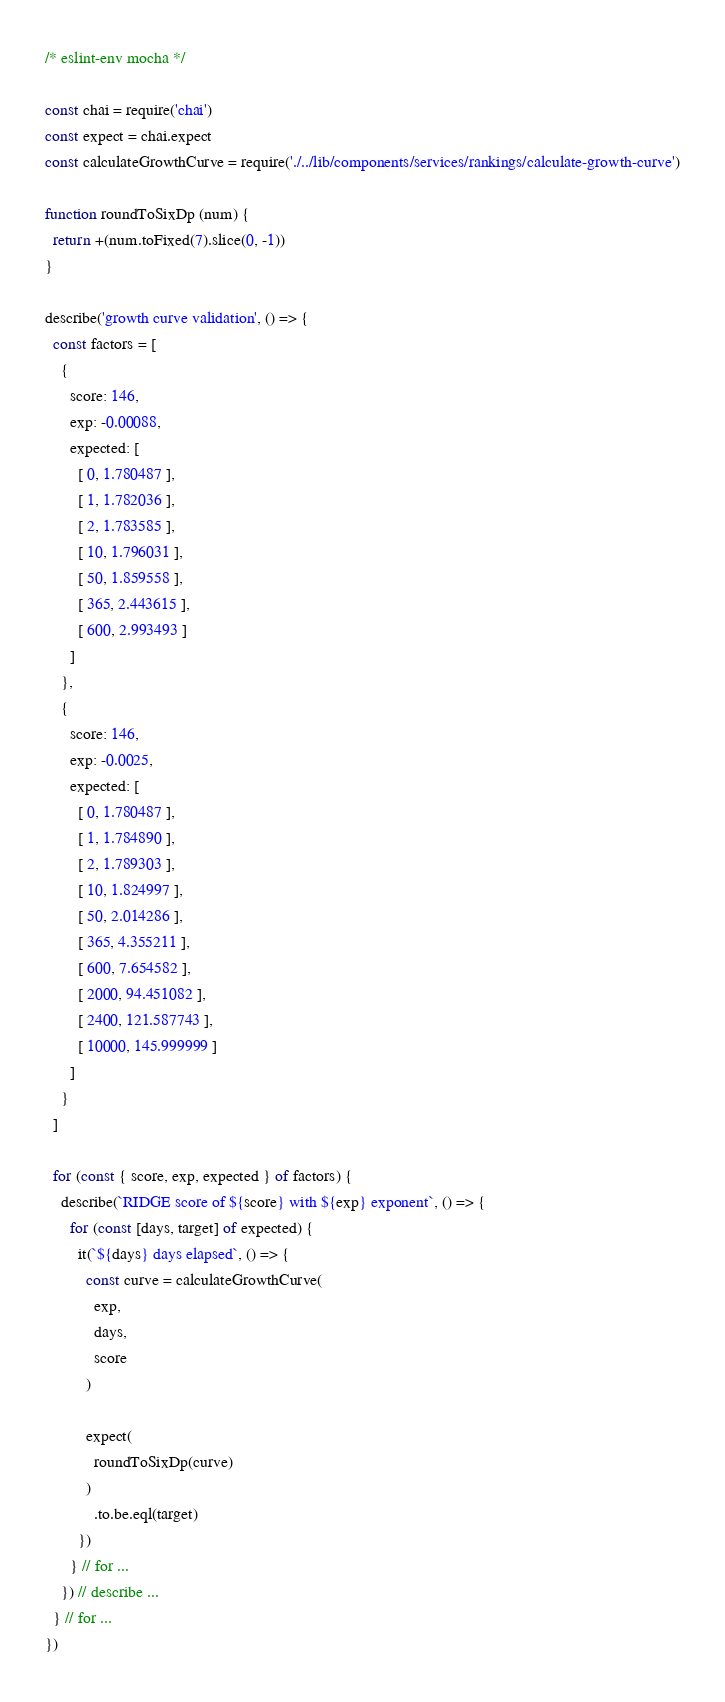Convert code to text. <code><loc_0><loc_0><loc_500><loc_500><_JavaScript_>/* eslint-env mocha */

const chai = require('chai')
const expect = chai.expect
const calculateGrowthCurve = require('./../lib/components/services/rankings/calculate-growth-curve')

function roundToSixDp (num) {
  return +(num.toFixed(7).slice(0, -1))
}

describe('growth curve validation', () => {
  const factors = [
    {
      score: 146,
      exp: -0.00088,
      expected: [
        [ 0, 1.780487 ],
        [ 1, 1.782036 ],
        [ 2, 1.783585 ],
        [ 10, 1.796031 ],
        [ 50, 1.859558 ],
        [ 365, 2.443615 ],
        [ 600, 2.993493 ]
      ]
    },
    {
      score: 146,
      exp: -0.0025,
      expected: [
        [ 0, 1.780487 ],
        [ 1, 1.784890 ],
        [ 2, 1.789303 ],
        [ 10, 1.824997 ],
        [ 50, 2.014286 ],
        [ 365, 4.355211 ],
        [ 600, 7.654582 ],
        [ 2000, 94.451082 ],
        [ 2400, 121.587743 ],
        [ 10000, 145.999999 ]
      ]
    }
  ]

  for (const { score, exp, expected } of factors) {
    describe(`RIDGE score of ${score} with ${exp} exponent`, () => {
      for (const [days, target] of expected) {
        it(`${days} days elapsed`, () => {
          const curve = calculateGrowthCurve(
            exp,
            days,
            score
          )

          expect(
            roundToSixDp(curve)
          )
            .to.be.eql(target)
        })
      } // for ...
    }) // describe ...
  } // for ...
})
</code> 